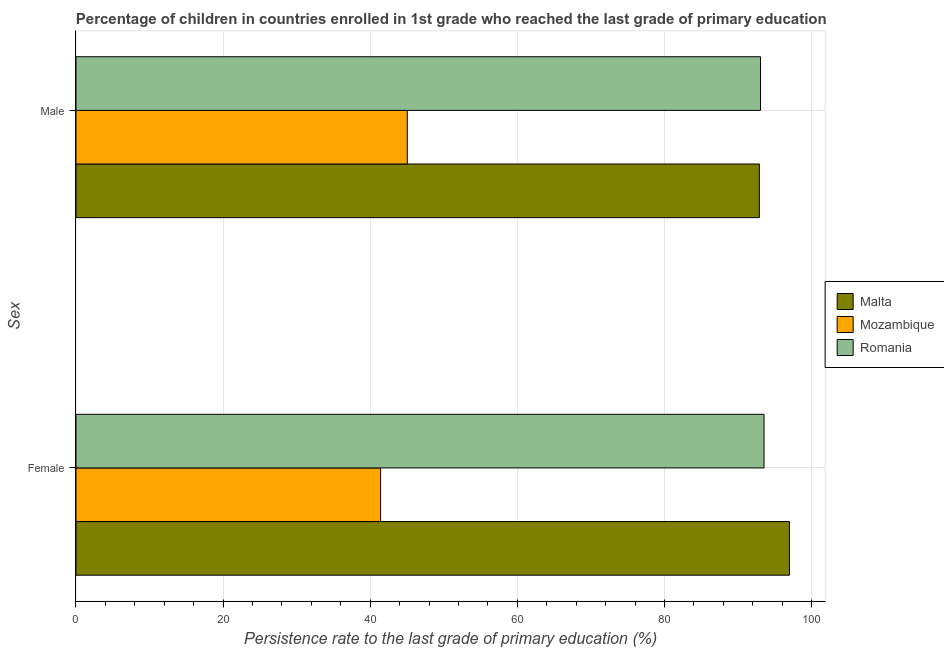How many different coloured bars are there?
Give a very brief answer. 3. How many groups of bars are there?
Your answer should be compact. 2. How many bars are there on the 1st tick from the top?
Provide a succinct answer. 3. What is the persistence rate of male students in Malta?
Offer a very short reply. 92.9. Across all countries, what is the maximum persistence rate of female students?
Offer a terse response. 97. Across all countries, what is the minimum persistence rate of female students?
Your response must be concise. 41.41. In which country was the persistence rate of female students maximum?
Ensure brevity in your answer.  Malta. In which country was the persistence rate of female students minimum?
Offer a terse response. Mozambique. What is the total persistence rate of male students in the graph?
Provide a short and direct response. 231. What is the difference between the persistence rate of female students in Mozambique and that in Malta?
Provide a succinct answer. -55.58. What is the difference between the persistence rate of male students in Romania and the persistence rate of female students in Mozambique?
Provide a short and direct response. 51.64. What is the average persistence rate of male students per country?
Keep it short and to the point. 77. What is the difference between the persistence rate of female students and persistence rate of male students in Mozambique?
Offer a very short reply. -3.63. What is the ratio of the persistence rate of female students in Malta to that in Mozambique?
Offer a very short reply. 2.34. Is the persistence rate of female students in Malta less than that in Romania?
Give a very brief answer. No. What does the 2nd bar from the top in Female represents?
Give a very brief answer. Mozambique. What does the 2nd bar from the bottom in Female represents?
Your response must be concise. Mozambique. How many bars are there?
Provide a short and direct response. 6. Are all the bars in the graph horizontal?
Your answer should be very brief. Yes. Does the graph contain grids?
Ensure brevity in your answer.  Yes. How many legend labels are there?
Give a very brief answer. 3. What is the title of the graph?
Keep it short and to the point. Percentage of children in countries enrolled in 1st grade who reached the last grade of primary education. What is the label or title of the X-axis?
Your answer should be compact. Persistence rate to the last grade of primary education (%). What is the label or title of the Y-axis?
Your answer should be compact. Sex. What is the Persistence rate to the last grade of primary education (%) in Malta in Female?
Offer a terse response. 97. What is the Persistence rate to the last grade of primary education (%) in Mozambique in Female?
Offer a terse response. 41.41. What is the Persistence rate to the last grade of primary education (%) in Romania in Female?
Offer a very short reply. 93.54. What is the Persistence rate to the last grade of primary education (%) of Malta in Male?
Provide a short and direct response. 92.9. What is the Persistence rate to the last grade of primary education (%) of Mozambique in Male?
Ensure brevity in your answer.  45.04. What is the Persistence rate to the last grade of primary education (%) in Romania in Male?
Provide a short and direct response. 93.06. Across all Sex, what is the maximum Persistence rate to the last grade of primary education (%) of Malta?
Your answer should be compact. 97. Across all Sex, what is the maximum Persistence rate to the last grade of primary education (%) of Mozambique?
Offer a terse response. 45.04. Across all Sex, what is the maximum Persistence rate to the last grade of primary education (%) of Romania?
Ensure brevity in your answer.  93.54. Across all Sex, what is the minimum Persistence rate to the last grade of primary education (%) of Malta?
Provide a succinct answer. 92.9. Across all Sex, what is the minimum Persistence rate to the last grade of primary education (%) of Mozambique?
Your answer should be very brief. 41.41. Across all Sex, what is the minimum Persistence rate to the last grade of primary education (%) in Romania?
Keep it short and to the point. 93.06. What is the total Persistence rate to the last grade of primary education (%) of Malta in the graph?
Offer a terse response. 189.9. What is the total Persistence rate to the last grade of primary education (%) of Mozambique in the graph?
Your answer should be compact. 86.45. What is the total Persistence rate to the last grade of primary education (%) of Romania in the graph?
Your answer should be very brief. 186.59. What is the difference between the Persistence rate to the last grade of primary education (%) of Malta in Female and that in Male?
Offer a terse response. 4.09. What is the difference between the Persistence rate to the last grade of primary education (%) in Mozambique in Female and that in Male?
Provide a succinct answer. -3.63. What is the difference between the Persistence rate to the last grade of primary education (%) in Romania in Female and that in Male?
Your response must be concise. 0.48. What is the difference between the Persistence rate to the last grade of primary education (%) in Malta in Female and the Persistence rate to the last grade of primary education (%) in Mozambique in Male?
Offer a terse response. 51.96. What is the difference between the Persistence rate to the last grade of primary education (%) in Malta in Female and the Persistence rate to the last grade of primary education (%) in Romania in Male?
Ensure brevity in your answer.  3.94. What is the difference between the Persistence rate to the last grade of primary education (%) in Mozambique in Female and the Persistence rate to the last grade of primary education (%) in Romania in Male?
Ensure brevity in your answer.  -51.64. What is the average Persistence rate to the last grade of primary education (%) of Malta per Sex?
Keep it short and to the point. 94.95. What is the average Persistence rate to the last grade of primary education (%) in Mozambique per Sex?
Your answer should be compact. 43.23. What is the average Persistence rate to the last grade of primary education (%) of Romania per Sex?
Your response must be concise. 93.3. What is the difference between the Persistence rate to the last grade of primary education (%) of Malta and Persistence rate to the last grade of primary education (%) of Mozambique in Female?
Your response must be concise. 55.58. What is the difference between the Persistence rate to the last grade of primary education (%) in Malta and Persistence rate to the last grade of primary education (%) in Romania in Female?
Offer a very short reply. 3.46. What is the difference between the Persistence rate to the last grade of primary education (%) of Mozambique and Persistence rate to the last grade of primary education (%) of Romania in Female?
Your answer should be very brief. -52.12. What is the difference between the Persistence rate to the last grade of primary education (%) in Malta and Persistence rate to the last grade of primary education (%) in Mozambique in Male?
Offer a very short reply. 47.86. What is the difference between the Persistence rate to the last grade of primary education (%) of Malta and Persistence rate to the last grade of primary education (%) of Romania in Male?
Provide a succinct answer. -0.15. What is the difference between the Persistence rate to the last grade of primary education (%) of Mozambique and Persistence rate to the last grade of primary education (%) of Romania in Male?
Give a very brief answer. -48.02. What is the ratio of the Persistence rate to the last grade of primary education (%) of Malta in Female to that in Male?
Your answer should be very brief. 1.04. What is the ratio of the Persistence rate to the last grade of primary education (%) in Mozambique in Female to that in Male?
Your answer should be compact. 0.92. What is the difference between the highest and the second highest Persistence rate to the last grade of primary education (%) of Malta?
Your answer should be compact. 4.09. What is the difference between the highest and the second highest Persistence rate to the last grade of primary education (%) of Mozambique?
Make the answer very short. 3.63. What is the difference between the highest and the second highest Persistence rate to the last grade of primary education (%) of Romania?
Provide a succinct answer. 0.48. What is the difference between the highest and the lowest Persistence rate to the last grade of primary education (%) in Malta?
Keep it short and to the point. 4.09. What is the difference between the highest and the lowest Persistence rate to the last grade of primary education (%) in Mozambique?
Your answer should be compact. 3.63. What is the difference between the highest and the lowest Persistence rate to the last grade of primary education (%) of Romania?
Provide a short and direct response. 0.48. 